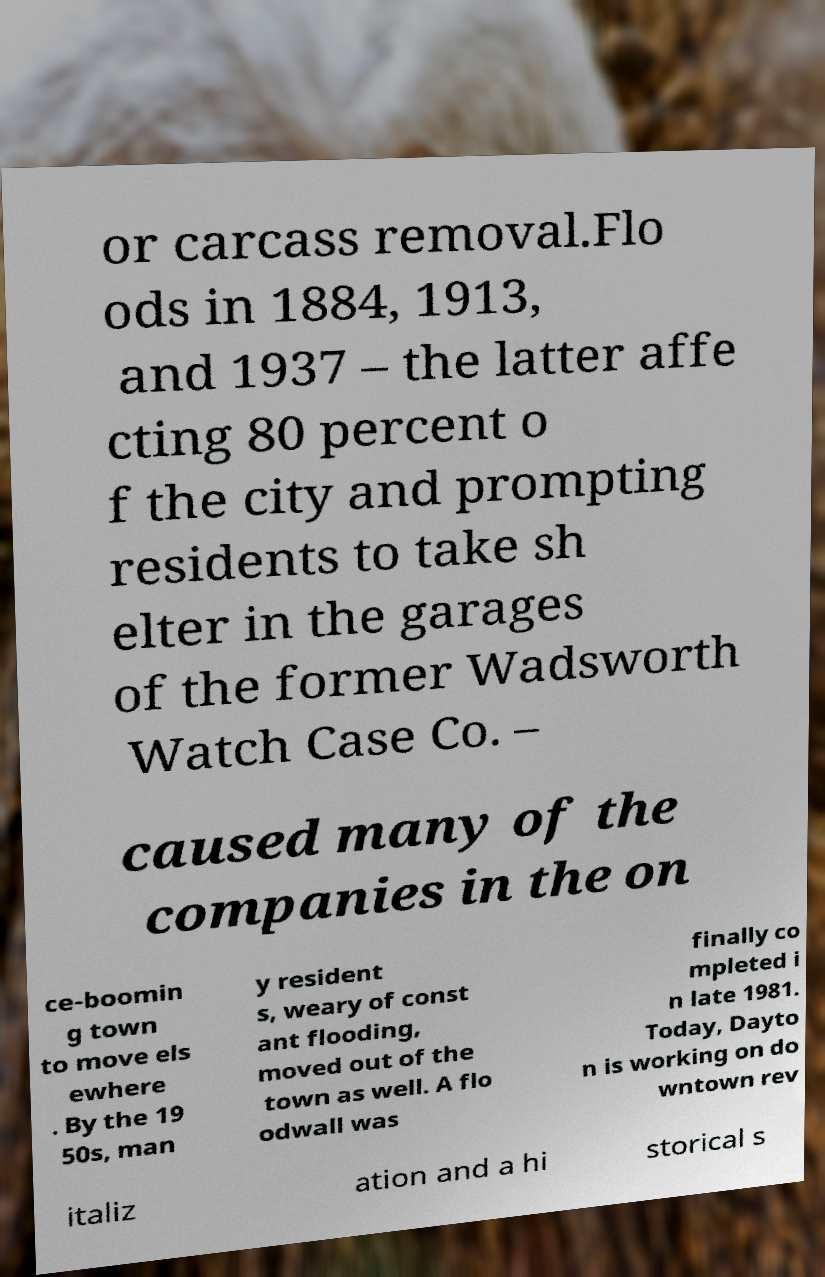For documentation purposes, I need the text within this image transcribed. Could you provide that? or carcass removal.Flo ods in 1884, 1913, and 1937 – the latter affe cting 80 percent o f the city and prompting residents to take sh elter in the garages of the former Wadsworth Watch Case Co. – caused many of the companies in the on ce-boomin g town to move els ewhere . By the 19 50s, man y resident s, weary of const ant flooding, moved out of the town as well. A flo odwall was finally co mpleted i n late 1981. Today, Dayto n is working on do wntown rev italiz ation and a hi storical s 